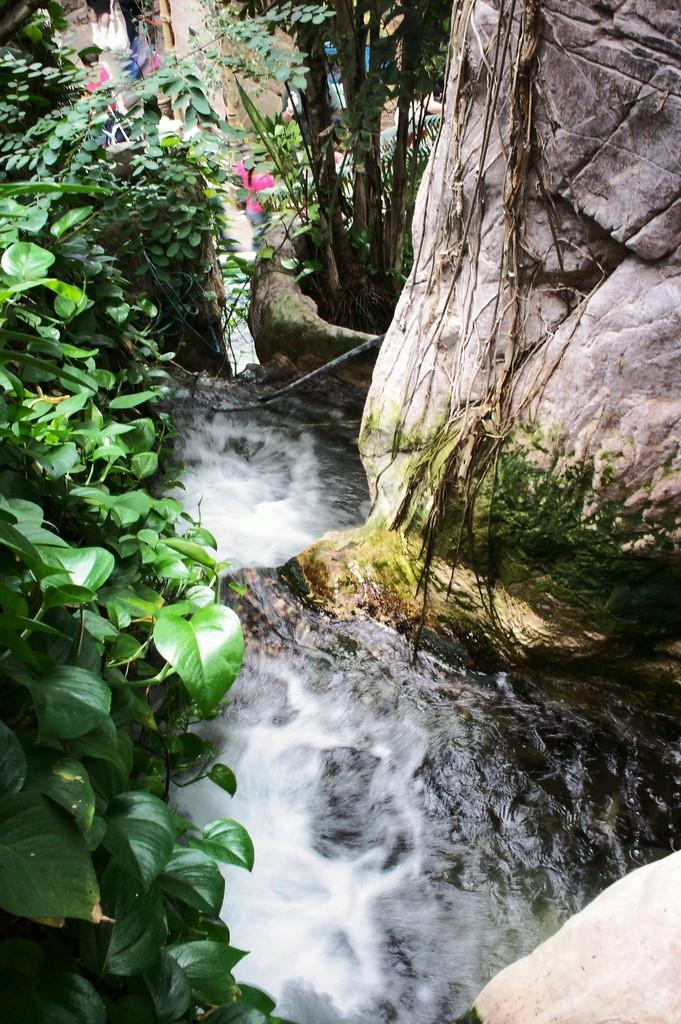What type of natural elements can be seen in the image? There are trees and water visible in the image. What else can be observed in the image besides the natural elements? There are people standing in the image. Are there any other objects or features present in the image? Yes, there are rocks in the image. Can you tell me how many maids are present in the image? There are no maids present in the image; it features trees, water, people, and rocks. 